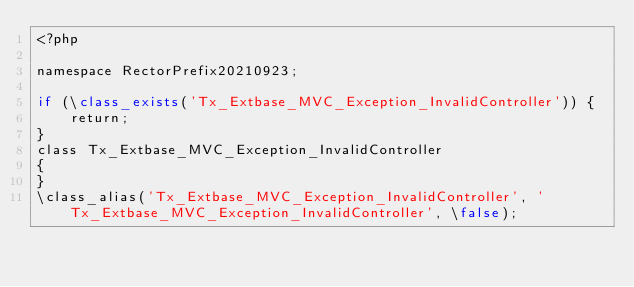Convert code to text. <code><loc_0><loc_0><loc_500><loc_500><_PHP_><?php

namespace RectorPrefix20210923;

if (\class_exists('Tx_Extbase_MVC_Exception_InvalidController')) {
    return;
}
class Tx_Extbase_MVC_Exception_InvalidController
{
}
\class_alias('Tx_Extbase_MVC_Exception_InvalidController', 'Tx_Extbase_MVC_Exception_InvalidController', \false);
</code> 